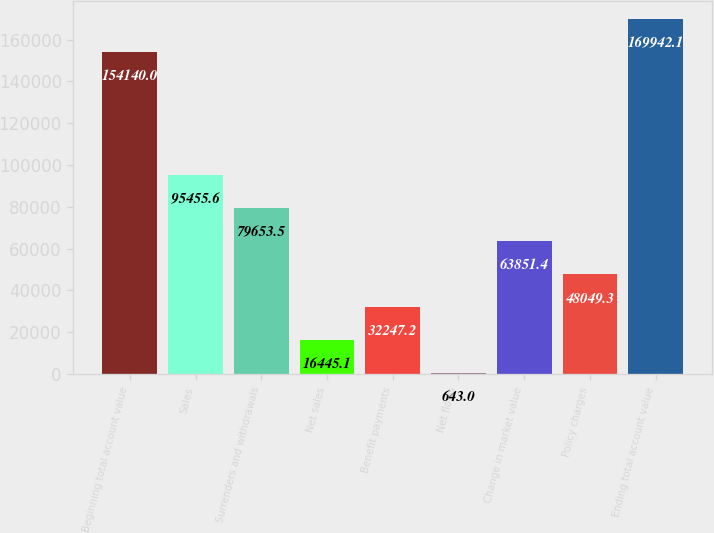<chart> <loc_0><loc_0><loc_500><loc_500><bar_chart><fcel>Beginning total account value<fcel>Sales<fcel>Surrenders and withdrawals<fcel>Net sales<fcel>Benefit payments<fcel>Net flows<fcel>Change in market value<fcel>Policy charges<fcel>Ending total account value<nl><fcel>154140<fcel>95455.6<fcel>79653.5<fcel>16445.1<fcel>32247.2<fcel>643<fcel>63851.4<fcel>48049.3<fcel>169942<nl></chart> 